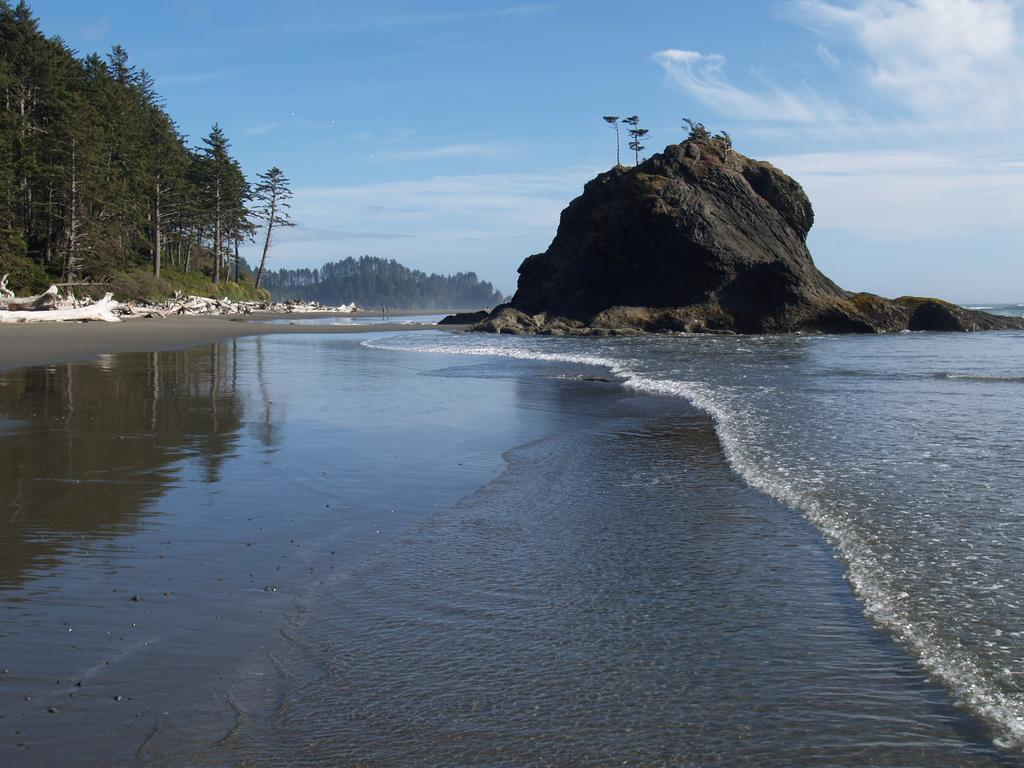What is the primary element visible in the image? There is a water surface in the image. What type of landform can be seen in the image? There is a hill visible in the image. What type of vegetation is present in the image? There are trees in the image. What type of pickle is floating on the water surface in the image? There is no pickle present in the image; it only features a water surface, a hill, and trees. What type of stick can be seen leaning against the hill in the image? There is no stick present in the image; it only features a water surface, a hill, and trees. 